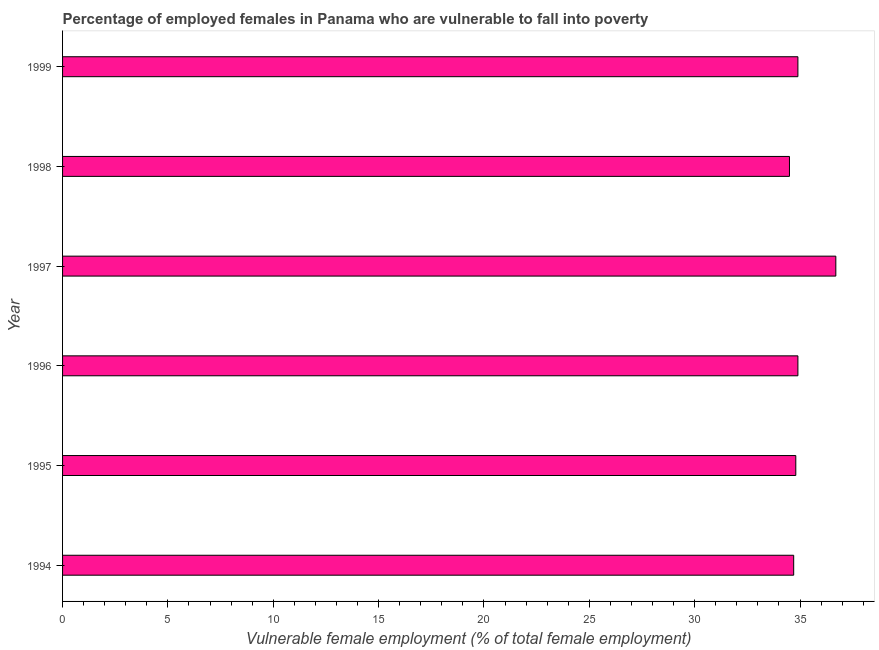Does the graph contain any zero values?
Your response must be concise. No. What is the title of the graph?
Provide a succinct answer. Percentage of employed females in Panama who are vulnerable to fall into poverty. What is the label or title of the X-axis?
Your answer should be compact. Vulnerable female employment (% of total female employment). What is the label or title of the Y-axis?
Offer a very short reply. Year. What is the percentage of employed females who are vulnerable to fall into poverty in 1997?
Ensure brevity in your answer.  36.7. Across all years, what is the maximum percentage of employed females who are vulnerable to fall into poverty?
Your answer should be compact. 36.7. Across all years, what is the minimum percentage of employed females who are vulnerable to fall into poverty?
Your response must be concise. 34.5. What is the sum of the percentage of employed females who are vulnerable to fall into poverty?
Offer a terse response. 210.5. What is the average percentage of employed females who are vulnerable to fall into poverty per year?
Ensure brevity in your answer.  35.08. What is the median percentage of employed females who are vulnerable to fall into poverty?
Offer a terse response. 34.85. In how many years, is the percentage of employed females who are vulnerable to fall into poverty greater than 25 %?
Offer a terse response. 6. What is the ratio of the percentage of employed females who are vulnerable to fall into poverty in 1994 to that in 1999?
Ensure brevity in your answer.  0.99. Is the percentage of employed females who are vulnerable to fall into poverty in 1997 less than that in 1998?
Ensure brevity in your answer.  No. What is the difference between the highest and the second highest percentage of employed females who are vulnerable to fall into poverty?
Ensure brevity in your answer.  1.8. Is the sum of the percentage of employed females who are vulnerable to fall into poverty in 1996 and 1997 greater than the maximum percentage of employed females who are vulnerable to fall into poverty across all years?
Provide a short and direct response. Yes. In how many years, is the percentage of employed females who are vulnerable to fall into poverty greater than the average percentage of employed females who are vulnerable to fall into poverty taken over all years?
Give a very brief answer. 1. Are all the bars in the graph horizontal?
Make the answer very short. Yes. Are the values on the major ticks of X-axis written in scientific E-notation?
Keep it short and to the point. No. What is the Vulnerable female employment (% of total female employment) of 1994?
Give a very brief answer. 34.7. What is the Vulnerable female employment (% of total female employment) in 1995?
Your answer should be compact. 34.8. What is the Vulnerable female employment (% of total female employment) in 1996?
Your response must be concise. 34.9. What is the Vulnerable female employment (% of total female employment) in 1997?
Provide a succinct answer. 36.7. What is the Vulnerable female employment (% of total female employment) of 1998?
Provide a short and direct response. 34.5. What is the Vulnerable female employment (% of total female employment) of 1999?
Give a very brief answer. 34.9. What is the difference between the Vulnerable female employment (% of total female employment) in 1994 and 1999?
Your response must be concise. -0.2. What is the difference between the Vulnerable female employment (% of total female employment) in 1995 and 1996?
Your answer should be compact. -0.1. What is the difference between the Vulnerable female employment (% of total female employment) in 1995 and 1997?
Offer a terse response. -1.9. What is the difference between the Vulnerable female employment (% of total female employment) in 1995 and 1998?
Offer a very short reply. 0.3. What is the difference between the Vulnerable female employment (% of total female employment) in 1996 and 1999?
Ensure brevity in your answer.  0. What is the difference between the Vulnerable female employment (% of total female employment) in 1997 and 1998?
Ensure brevity in your answer.  2.2. What is the ratio of the Vulnerable female employment (% of total female employment) in 1994 to that in 1995?
Make the answer very short. 1. What is the ratio of the Vulnerable female employment (% of total female employment) in 1994 to that in 1996?
Provide a succinct answer. 0.99. What is the ratio of the Vulnerable female employment (% of total female employment) in 1994 to that in 1997?
Give a very brief answer. 0.95. What is the ratio of the Vulnerable female employment (% of total female employment) in 1994 to that in 1998?
Give a very brief answer. 1.01. What is the ratio of the Vulnerable female employment (% of total female employment) in 1994 to that in 1999?
Your answer should be very brief. 0.99. What is the ratio of the Vulnerable female employment (% of total female employment) in 1995 to that in 1997?
Keep it short and to the point. 0.95. What is the ratio of the Vulnerable female employment (% of total female employment) in 1996 to that in 1997?
Provide a short and direct response. 0.95. What is the ratio of the Vulnerable female employment (% of total female employment) in 1996 to that in 1998?
Offer a terse response. 1.01. What is the ratio of the Vulnerable female employment (% of total female employment) in 1997 to that in 1998?
Offer a very short reply. 1.06. What is the ratio of the Vulnerable female employment (% of total female employment) in 1997 to that in 1999?
Your answer should be very brief. 1.05. 